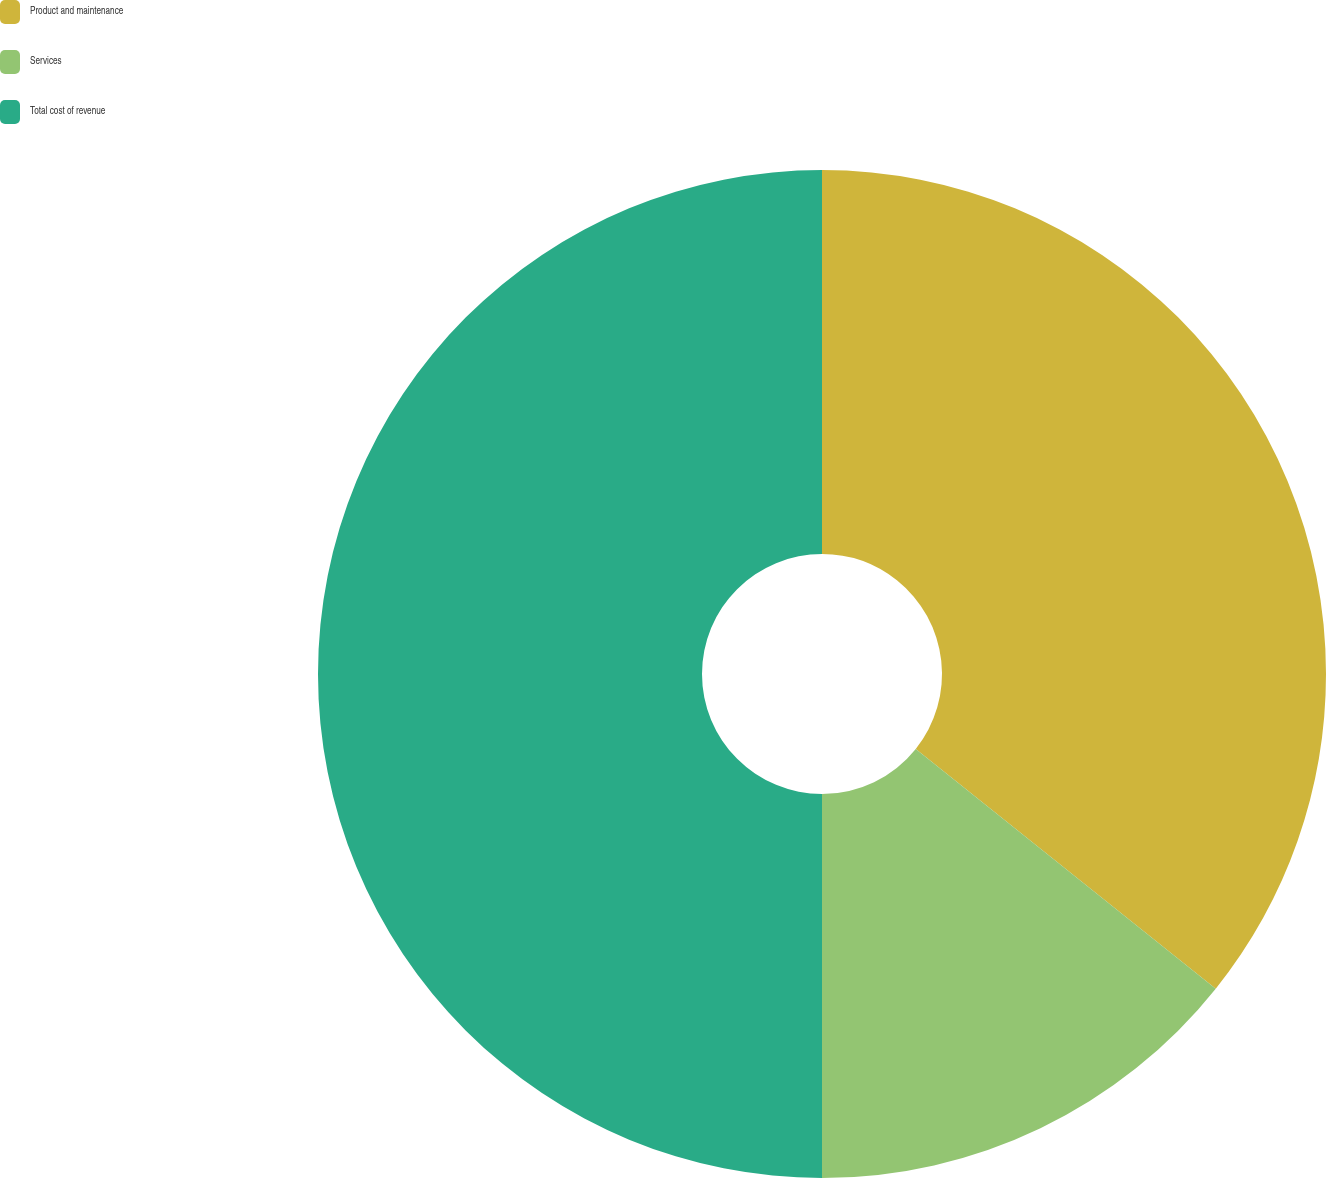Convert chart. <chart><loc_0><loc_0><loc_500><loc_500><pie_chart><fcel>Product and maintenance<fcel>Services<fcel>Total cost of revenue<nl><fcel>35.73%<fcel>14.27%<fcel>50.0%<nl></chart> 